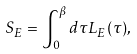<formula> <loc_0><loc_0><loc_500><loc_500>S _ { E } = \int _ { 0 } ^ { \beta } d \tau L _ { E } ( \tau ) ,</formula> 